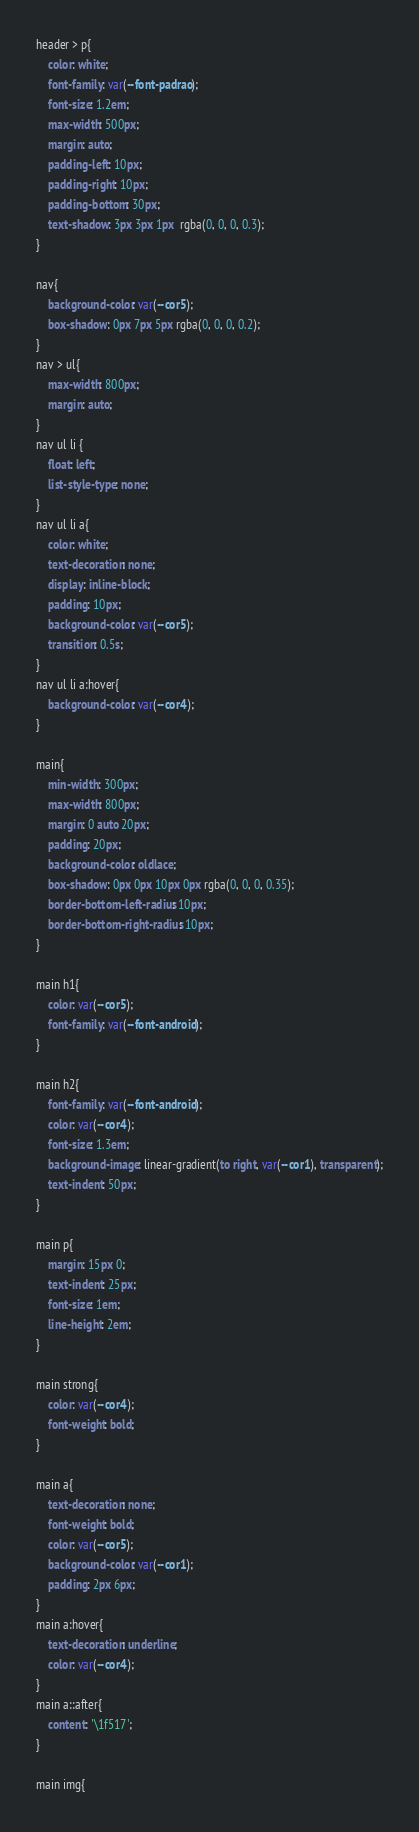Convert code to text. <code><loc_0><loc_0><loc_500><loc_500><_CSS_>
header > p{
    color: white;
    font-family: var(--font-padrao);
    font-size: 1.2em;
    max-width: 500px;
    margin: auto;
    padding-left: 10px;
    padding-right: 10px;
    padding-bottom: 30px;
    text-shadow: 3px 3px 1px  rgba(0, 0, 0, 0.3);
}

nav{
    background-color: var(--cor5);
    box-shadow: 0px 7px 5px rgba(0, 0, 0, 0.2);
}
nav > ul{
    max-width: 800px;
    margin: auto;
}
nav ul li {
    float: left;
    list-style-type: none;
}
nav ul li a{
    color: white;
    text-decoration: none;
    display: inline-block;
    padding: 10px;
    background-color: var(--cor5);
    transition: 0.5s;
}
nav ul li a:hover{
    background-color: var(--cor4);
}

main{
    min-width: 300px;
    max-width: 800px;
    margin: 0 auto 20px;
    padding: 20px;
    background-color: oldlace;
    box-shadow: 0px 0px 10px 0px rgba(0, 0, 0, 0.35);
    border-bottom-left-radius: 10px;
    border-bottom-right-radius: 10px;
}

main h1{
    color: var(--cor5);
    font-family: var(--font-android);
}

main h2{
    font-family: var(--font-android);
    color: var(--cor4);
    font-size: 1.3em;
    background-image: linear-gradient(to right, var(--cor1), transparent);
    text-indent: 50px;
}

main p{
    margin: 15px 0;
    text-indent: 25px;
    font-size: 1em;
    line-height: 2em;
}

main strong{
    color: var(--cor4);
    font-weight: bold;
}

main a{
    text-decoration: none;
    font-weight: bold;
    color: var(--cor5);
    background-color: var(--cor1);
    padding: 2px 6px;
}
main a:hover{
    text-decoration: underline;
    color: var(--cor4);
}
main a::after{
    content: '\1f517';
}

main img{</code> 